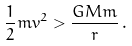<formula> <loc_0><loc_0><loc_500><loc_500>\frac { 1 } { 2 } m v ^ { 2 } > \frac { G M m } { r } \, .</formula> 